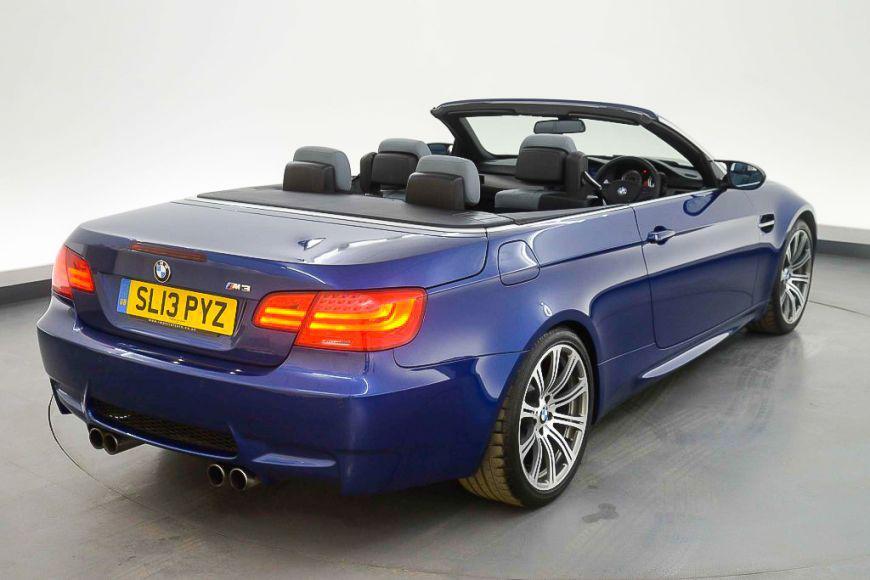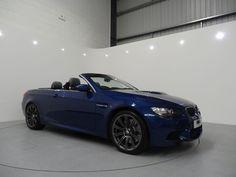The first image is the image on the left, the second image is the image on the right. For the images shown, is this caption "In both images the car has it's top down." true? Answer yes or no. Yes. The first image is the image on the left, the second image is the image on the right. Considering the images on both sides, is "The left image contains a royal blue topless convertible displayed at an angle on a gray surface." valid? Answer yes or no. Yes. 